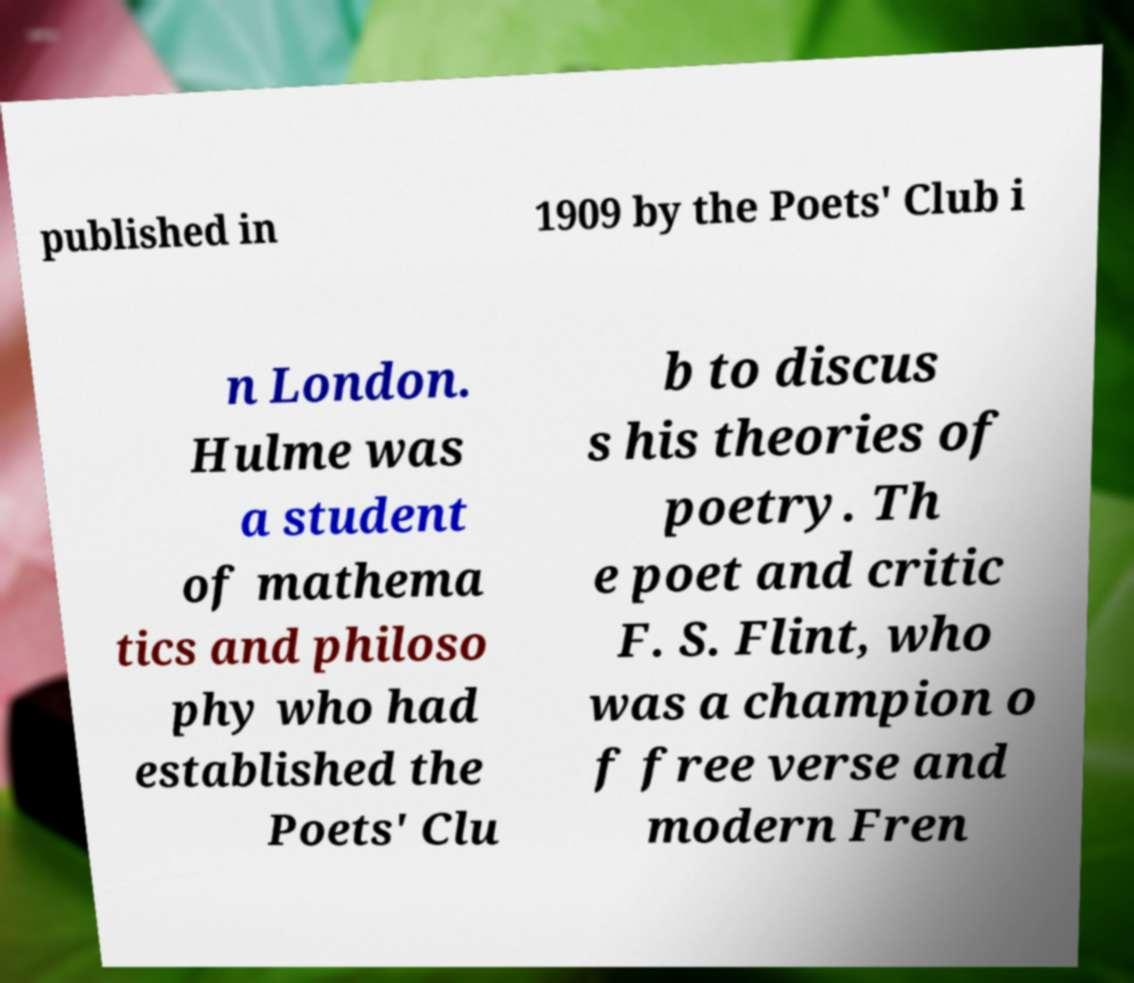There's text embedded in this image that I need extracted. Can you transcribe it verbatim? published in 1909 by the Poets' Club i n London. Hulme was a student of mathema tics and philoso phy who had established the Poets' Clu b to discus s his theories of poetry. Th e poet and critic F. S. Flint, who was a champion o f free verse and modern Fren 